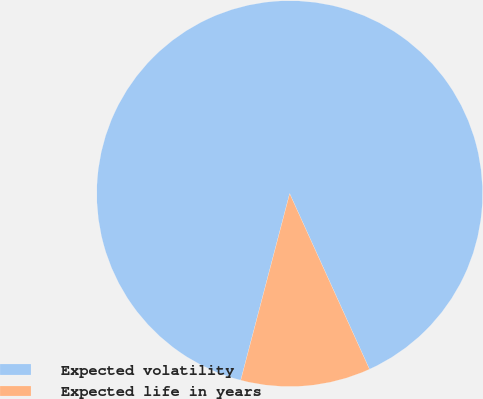<chart> <loc_0><loc_0><loc_500><loc_500><pie_chart><fcel>Expected volatility<fcel>Expected life in years<nl><fcel>89.13%<fcel>10.87%<nl></chart> 